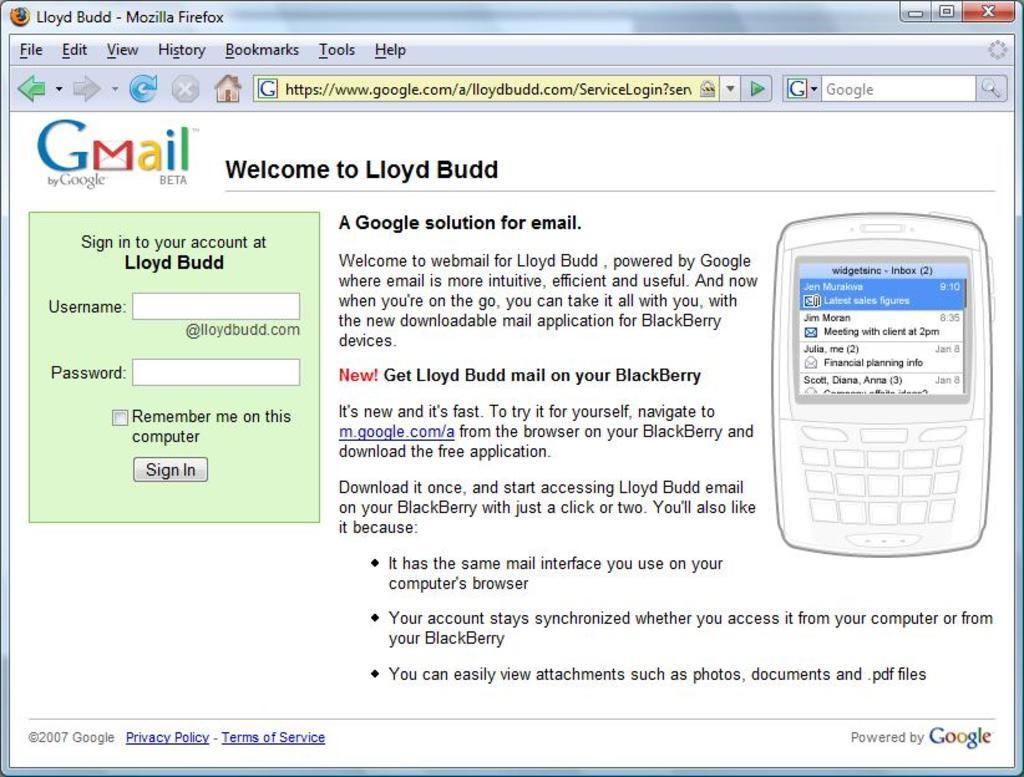Who does the account belong to?
Your response must be concise. Lloyd budd. What email service is this?
Provide a succinct answer. Gmail. 